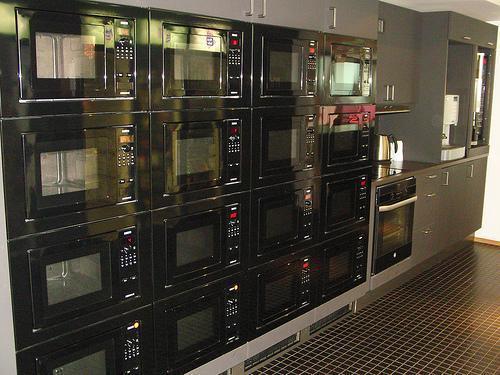How many conventional ovens are there?
Give a very brief answer. 1. 